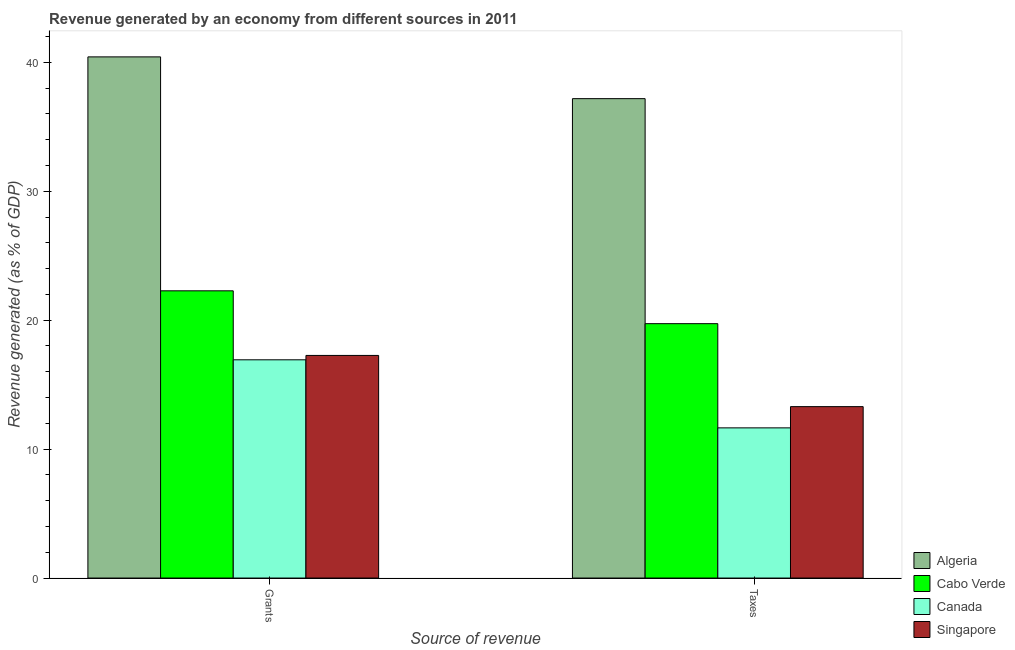How many different coloured bars are there?
Provide a short and direct response. 4. How many groups of bars are there?
Ensure brevity in your answer.  2. How many bars are there on the 2nd tick from the left?
Give a very brief answer. 4. How many bars are there on the 2nd tick from the right?
Your answer should be very brief. 4. What is the label of the 2nd group of bars from the left?
Keep it short and to the point. Taxes. What is the revenue generated by taxes in Cabo Verde?
Make the answer very short. 19.73. Across all countries, what is the maximum revenue generated by taxes?
Keep it short and to the point. 37.19. Across all countries, what is the minimum revenue generated by grants?
Provide a short and direct response. 16.93. In which country was the revenue generated by taxes maximum?
Make the answer very short. Algeria. What is the total revenue generated by grants in the graph?
Provide a succinct answer. 96.9. What is the difference between the revenue generated by grants in Cabo Verde and that in Singapore?
Your response must be concise. 5.01. What is the difference between the revenue generated by grants in Singapore and the revenue generated by taxes in Cabo Verde?
Ensure brevity in your answer.  -2.46. What is the average revenue generated by grants per country?
Provide a succinct answer. 24.23. What is the difference between the revenue generated by grants and revenue generated by taxes in Algeria?
Keep it short and to the point. 3.24. In how many countries, is the revenue generated by grants greater than 34 %?
Offer a very short reply. 1. What is the ratio of the revenue generated by grants in Singapore to that in Algeria?
Your answer should be compact. 0.43. Is the revenue generated by taxes in Cabo Verde less than that in Singapore?
Offer a terse response. No. What does the 1st bar from the left in Taxes represents?
Your answer should be very brief. Algeria. What does the 4th bar from the right in Grants represents?
Offer a terse response. Algeria. Are the values on the major ticks of Y-axis written in scientific E-notation?
Your response must be concise. No. Does the graph contain grids?
Provide a short and direct response. No. Where does the legend appear in the graph?
Make the answer very short. Bottom right. What is the title of the graph?
Offer a very short reply. Revenue generated by an economy from different sources in 2011. Does "United Kingdom" appear as one of the legend labels in the graph?
Keep it short and to the point. No. What is the label or title of the X-axis?
Offer a terse response. Source of revenue. What is the label or title of the Y-axis?
Give a very brief answer. Revenue generated (as % of GDP). What is the Revenue generated (as % of GDP) in Algeria in Grants?
Keep it short and to the point. 40.43. What is the Revenue generated (as % of GDP) in Cabo Verde in Grants?
Offer a very short reply. 22.28. What is the Revenue generated (as % of GDP) of Canada in Grants?
Keep it short and to the point. 16.93. What is the Revenue generated (as % of GDP) in Singapore in Grants?
Your answer should be compact. 17.27. What is the Revenue generated (as % of GDP) in Algeria in Taxes?
Give a very brief answer. 37.19. What is the Revenue generated (as % of GDP) of Cabo Verde in Taxes?
Offer a terse response. 19.73. What is the Revenue generated (as % of GDP) of Canada in Taxes?
Ensure brevity in your answer.  11.65. What is the Revenue generated (as % of GDP) in Singapore in Taxes?
Give a very brief answer. 13.3. Across all Source of revenue, what is the maximum Revenue generated (as % of GDP) of Algeria?
Your answer should be very brief. 40.43. Across all Source of revenue, what is the maximum Revenue generated (as % of GDP) in Cabo Verde?
Provide a succinct answer. 22.28. Across all Source of revenue, what is the maximum Revenue generated (as % of GDP) of Canada?
Keep it short and to the point. 16.93. Across all Source of revenue, what is the maximum Revenue generated (as % of GDP) of Singapore?
Offer a terse response. 17.27. Across all Source of revenue, what is the minimum Revenue generated (as % of GDP) of Algeria?
Provide a succinct answer. 37.19. Across all Source of revenue, what is the minimum Revenue generated (as % of GDP) in Cabo Verde?
Keep it short and to the point. 19.73. Across all Source of revenue, what is the minimum Revenue generated (as % of GDP) in Canada?
Offer a very short reply. 11.65. Across all Source of revenue, what is the minimum Revenue generated (as % of GDP) of Singapore?
Make the answer very short. 13.3. What is the total Revenue generated (as % of GDP) in Algeria in the graph?
Keep it short and to the point. 77.61. What is the total Revenue generated (as % of GDP) of Cabo Verde in the graph?
Your answer should be very brief. 42.01. What is the total Revenue generated (as % of GDP) of Canada in the graph?
Provide a succinct answer. 28.58. What is the total Revenue generated (as % of GDP) in Singapore in the graph?
Keep it short and to the point. 30.56. What is the difference between the Revenue generated (as % of GDP) in Algeria in Grants and that in Taxes?
Your answer should be compact. 3.24. What is the difference between the Revenue generated (as % of GDP) in Cabo Verde in Grants and that in Taxes?
Ensure brevity in your answer.  2.55. What is the difference between the Revenue generated (as % of GDP) of Canada in Grants and that in Taxes?
Provide a short and direct response. 5.28. What is the difference between the Revenue generated (as % of GDP) of Singapore in Grants and that in Taxes?
Keep it short and to the point. 3.97. What is the difference between the Revenue generated (as % of GDP) of Algeria in Grants and the Revenue generated (as % of GDP) of Cabo Verde in Taxes?
Provide a succinct answer. 20.69. What is the difference between the Revenue generated (as % of GDP) of Algeria in Grants and the Revenue generated (as % of GDP) of Canada in Taxes?
Provide a succinct answer. 28.78. What is the difference between the Revenue generated (as % of GDP) of Algeria in Grants and the Revenue generated (as % of GDP) of Singapore in Taxes?
Your answer should be very brief. 27.13. What is the difference between the Revenue generated (as % of GDP) of Cabo Verde in Grants and the Revenue generated (as % of GDP) of Canada in Taxes?
Your response must be concise. 10.63. What is the difference between the Revenue generated (as % of GDP) in Cabo Verde in Grants and the Revenue generated (as % of GDP) in Singapore in Taxes?
Your response must be concise. 8.98. What is the difference between the Revenue generated (as % of GDP) of Canada in Grants and the Revenue generated (as % of GDP) of Singapore in Taxes?
Keep it short and to the point. 3.63. What is the average Revenue generated (as % of GDP) in Algeria per Source of revenue?
Give a very brief answer. 38.81. What is the average Revenue generated (as % of GDP) of Cabo Verde per Source of revenue?
Make the answer very short. 21.01. What is the average Revenue generated (as % of GDP) of Canada per Source of revenue?
Offer a terse response. 14.29. What is the average Revenue generated (as % of GDP) in Singapore per Source of revenue?
Give a very brief answer. 15.28. What is the difference between the Revenue generated (as % of GDP) of Algeria and Revenue generated (as % of GDP) of Cabo Verde in Grants?
Give a very brief answer. 18.15. What is the difference between the Revenue generated (as % of GDP) of Algeria and Revenue generated (as % of GDP) of Canada in Grants?
Your answer should be compact. 23.5. What is the difference between the Revenue generated (as % of GDP) in Algeria and Revenue generated (as % of GDP) in Singapore in Grants?
Provide a short and direct response. 23.16. What is the difference between the Revenue generated (as % of GDP) in Cabo Verde and Revenue generated (as % of GDP) in Canada in Grants?
Your answer should be compact. 5.35. What is the difference between the Revenue generated (as % of GDP) of Cabo Verde and Revenue generated (as % of GDP) of Singapore in Grants?
Give a very brief answer. 5.01. What is the difference between the Revenue generated (as % of GDP) of Canada and Revenue generated (as % of GDP) of Singapore in Grants?
Make the answer very short. -0.34. What is the difference between the Revenue generated (as % of GDP) of Algeria and Revenue generated (as % of GDP) of Cabo Verde in Taxes?
Your response must be concise. 17.45. What is the difference between the Revenue generated (as % of GDP) of Algeria and Revenue generated (as % of GDP) of Canada in Taxes?
Give a very brief answer. 25.54. What is the difference between the Revenue generated (as % of GDP) in Algeria and Revenue generated (as % of GDP) in Singapore in Taxes?
Give a very brief answer. 23.89. What is the difference between the Revenue generated (as % of GDP) of Cabo Verde and Revenue generated (as % of GDP) of Canada in Taxes?
Keep it short and to the point. 8.08. What is the difference between the Revenue generated (as % of GDP) of Cabo Verde and Revenue generated (as % of GDP) of Singapore in Taxes?
Your answer should be compact. 6.44. What is the difference between the Revenue generated (as % of GDP) in Canada and Revenue generated (as % of GDP) in Singapore in Taxes?
Ensure brevity in your answer.  -1.65. What is the ratio of the Revenue generated (as % of GDP) in Algeria in Grants to that in Taxes?
Offer a very short reply. 1.09. What is the ratio of the Revenue generated (as % of GDP) of Cabo Verde in Grants to that in Taxes?
Offer a terse response. 1.13. What is the ratio of the Revenue generated (as % of GDP) in Canada in Grants to that in Taxes?
Keep it short and to the point. 1.45. What is the ratio of the Revenue generated (as % of GDP) of Singapore in Grants to that in Taxes?
Provide a succinct answer. 1.3. What is the difference between the highest and the second highest Revenue generated (as % of GDP) of Algeria?
Your answer should be very brief. 3.24. What is the difference between the highest and the second highest Revenue generated (as % of GDP) in Cabo Verde?
Make the answer very short. 2.55. What is the difference between the highest and the second highest Revenue generated (as % of GDP) of Canada?
Give a very brief answer. 5.28. What is the difference between the highest and the second highest Revenue generated (as % of GDP) in Singapore?
Your answer should be very brief. 3.97. What is the difference between the highest and the lowest Revenue generated (as % of GDP) in Algeria?
Give a very brief answer. 3.24. What is the difference between the highest and the lowest Revenue generated (as % of GDP) of Cabo Verde?
Your answer should be compact. 2.55. What is the difference between the highest and the lowest Revenue generated (as % of GDP) in Canada?
Provide a short and direct response. 5.28. What is the difference between the highest and the lowest Revenue generated (as % of GDP) of Singapore?
Your answer should be very brief. 3.97. 